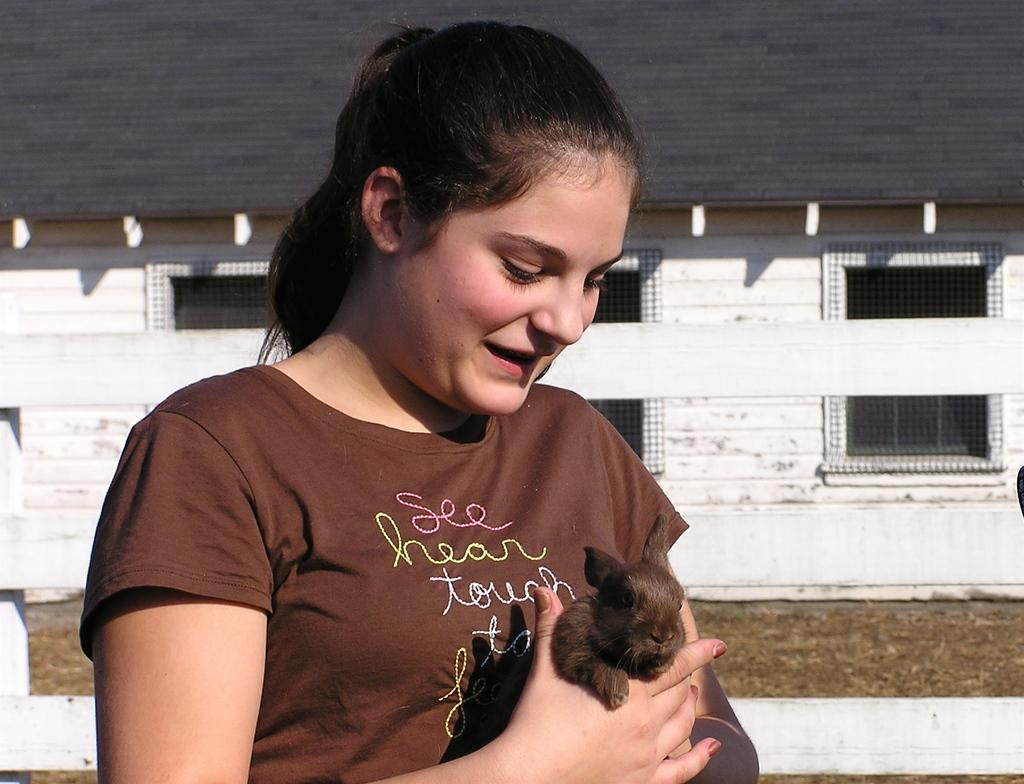Who is the main subject in the image? There is a girl in the image. What is the girl holding in the image? The girl is holding a rabbit. What can be seen in the background of the image? There is a building in the background of the image. What type of structure is present in the image? There is a fencing in the image. What type of record can be seen in the image? There is no record present in the image. How many eyes does the girl have in the image? The number of eyes the girl has cannot be determined from the image, but typically, humans have two eyes. 